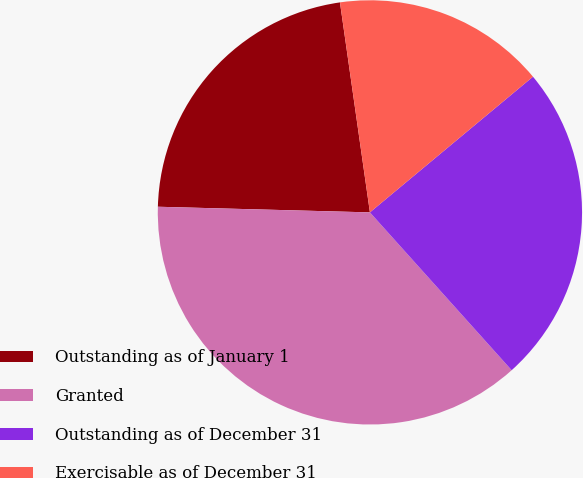Convert chart to OTSL. <chart><loc_0><loc_0><loc_500><loc_500><pie_chart><fcel>Outstanding as of January 1<fcel>Granted<fcel>Outstanding as of December 31<fcel>Exercisable as of December 31<nl><fcel>22.32%<fcel>37.07%<fcel>24.4%<fcel>16.21%<nl></chart> 